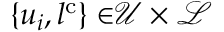Convert formula to latex. <formula><loc_0><loc_0><loc_500><loc_500>{ \{ u _ { i } , l ^ { c } \} \in } { \mathcal { U } \times \mathcal { L } }</formula> 